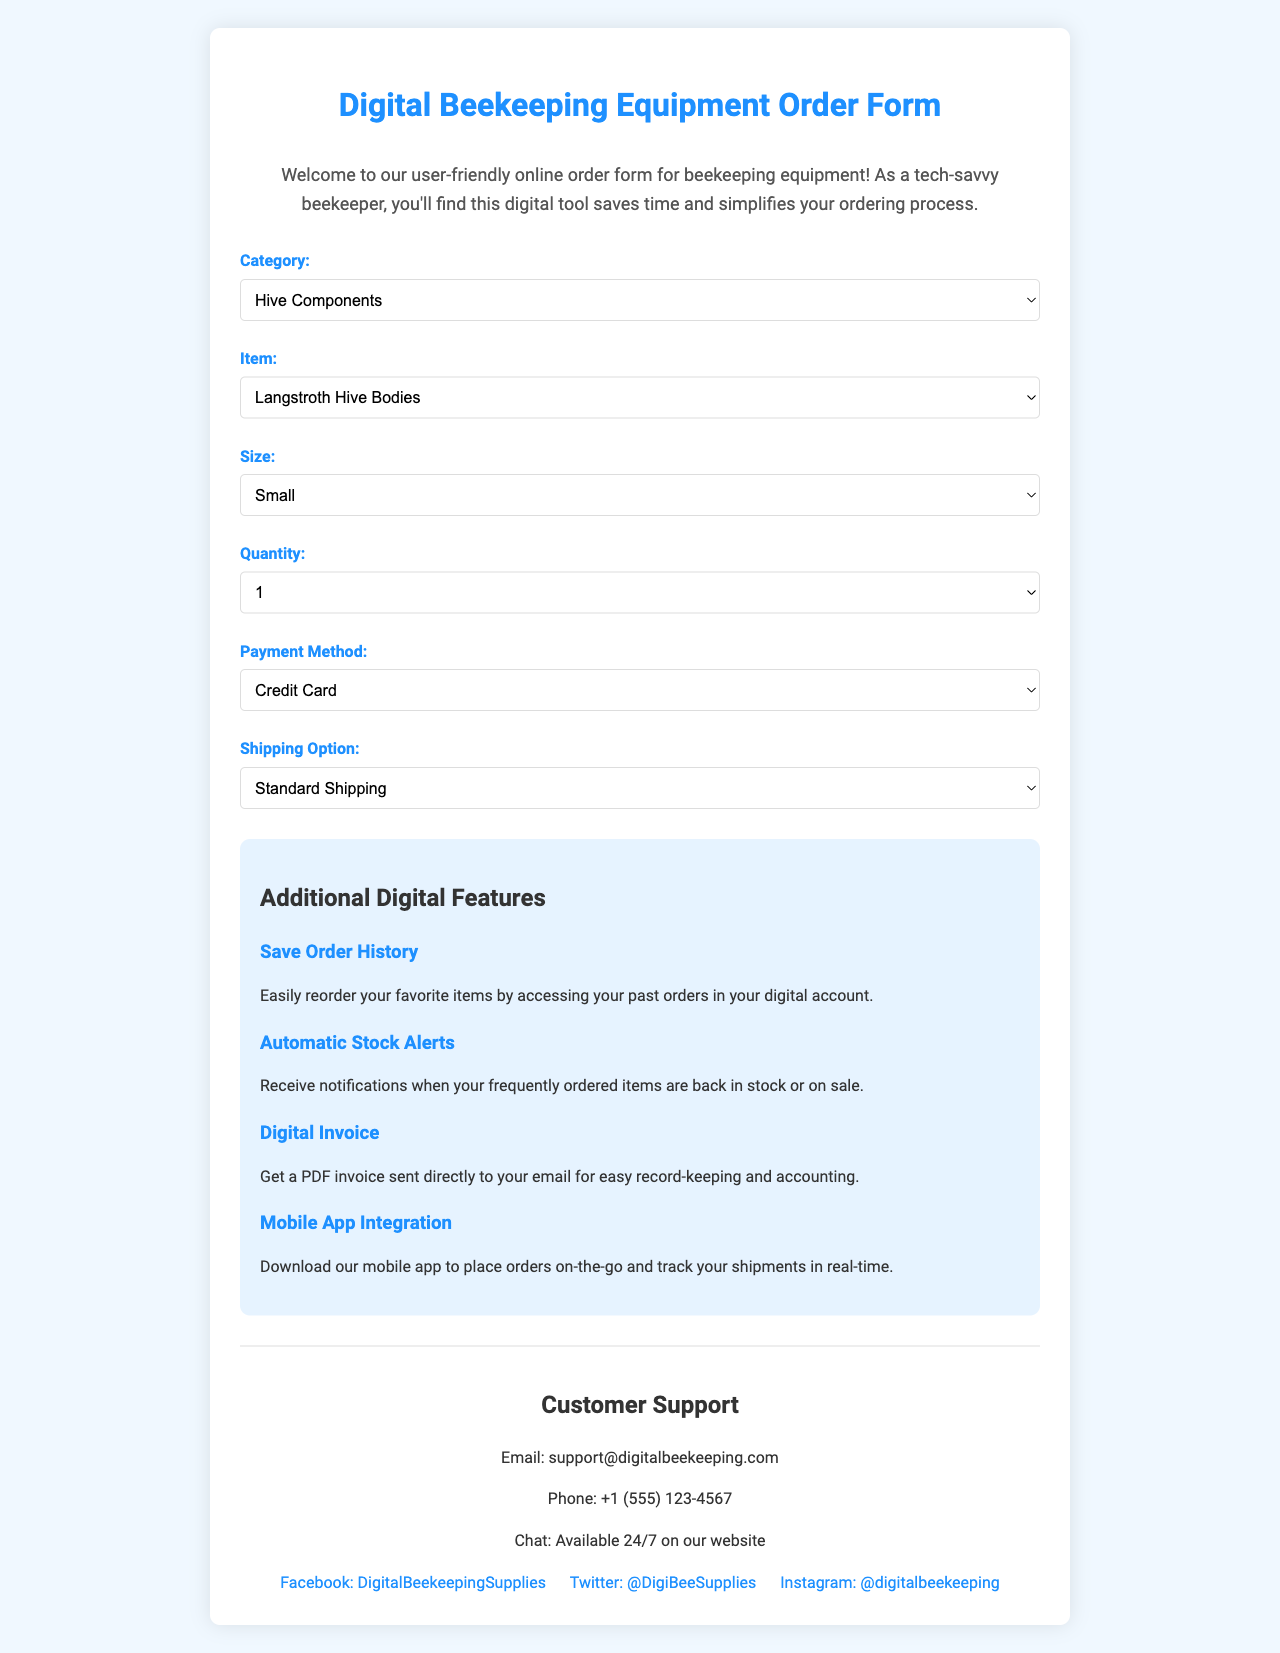what is the title of the form? The title of the form is mentioned at the top of the document.
Answer: Digital Beekeeping Equipment Order Form how many categories of equipment are listed? The number of categories listed is found in the categories section of the document.
Answer: 4 what method of payment is NOT included? The document lists various payment methods, and we can identify which one is missing by checking the payment methods section.
Answer: Cash what is an additional feature related to order history? The description of additional features includes one that talks about past orders.
Answer: Save Order History which shipping option is the fastest? The shipping options in the document indicate which one provides the quickest delivery.
Answer: Next Day Delivery what is the contact email for customer support? The customer support information section provides a specific email for inquiries.
Answer: support@digitalbeekeeping.com which type of protective gear is available in the form? The document specifies items available under a specific category of products.
Answer: Beekeeping Suits how many different sizes can be selected? The quantities of sizes available are indicated in the size selection area of the form.
Answer: 4 